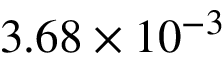Convert formula to latex. <formula><loc_0><loc_0><loc_500><loc_500>3 . 6 8 \times 1 0 ^ { - 3 }</formula> 